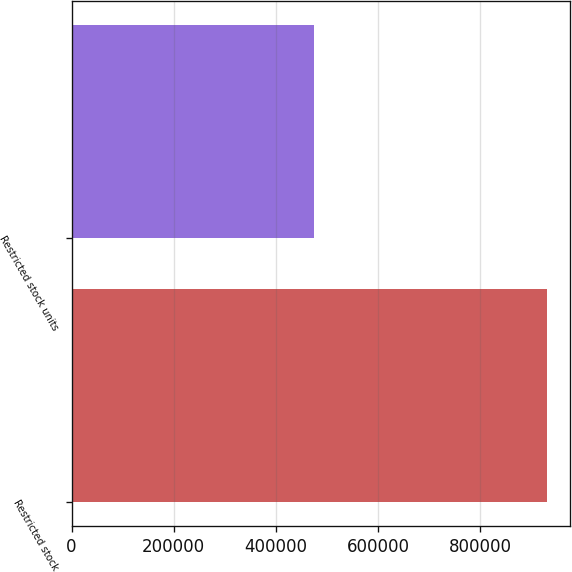Convert chart to OTSL. <chart><loc_0><loc_0><loc_500><loc_500><bar_chart><fcel>Restricted stock<fcel>Restricted stock units<nl><fcel>929990<fcel>475000<nl></chart> 